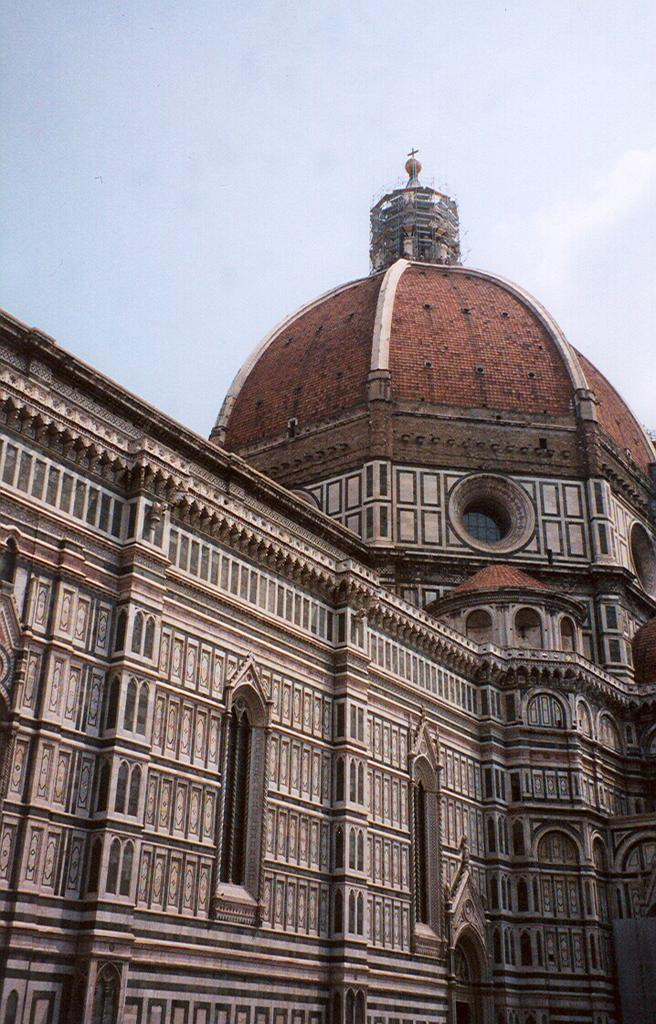What is the main structure visible in the image? There is a building in the front of the image. What part of the natural environment can be seen in the image? The sky is visible in the background of the image. Reasoning: Let's think step by identifying the main subjects and objects in the image based on the provided facts. We then formulate questions that focus on the location and characteristics of these subjects and objects, ensuring that each question can be answered definitively with the information given. We avoid yes/no questions and ensure that the language is simple and clear. Absurd Question/Answer: How many legs can be seen on the governor in the image? There is no governor present in the image, so it is not possible to determine the number of legs. How many laborers are working on the building in the image? There is no indication of laborers or any construction work in progress in the image. The image only shows a building and the sky. 